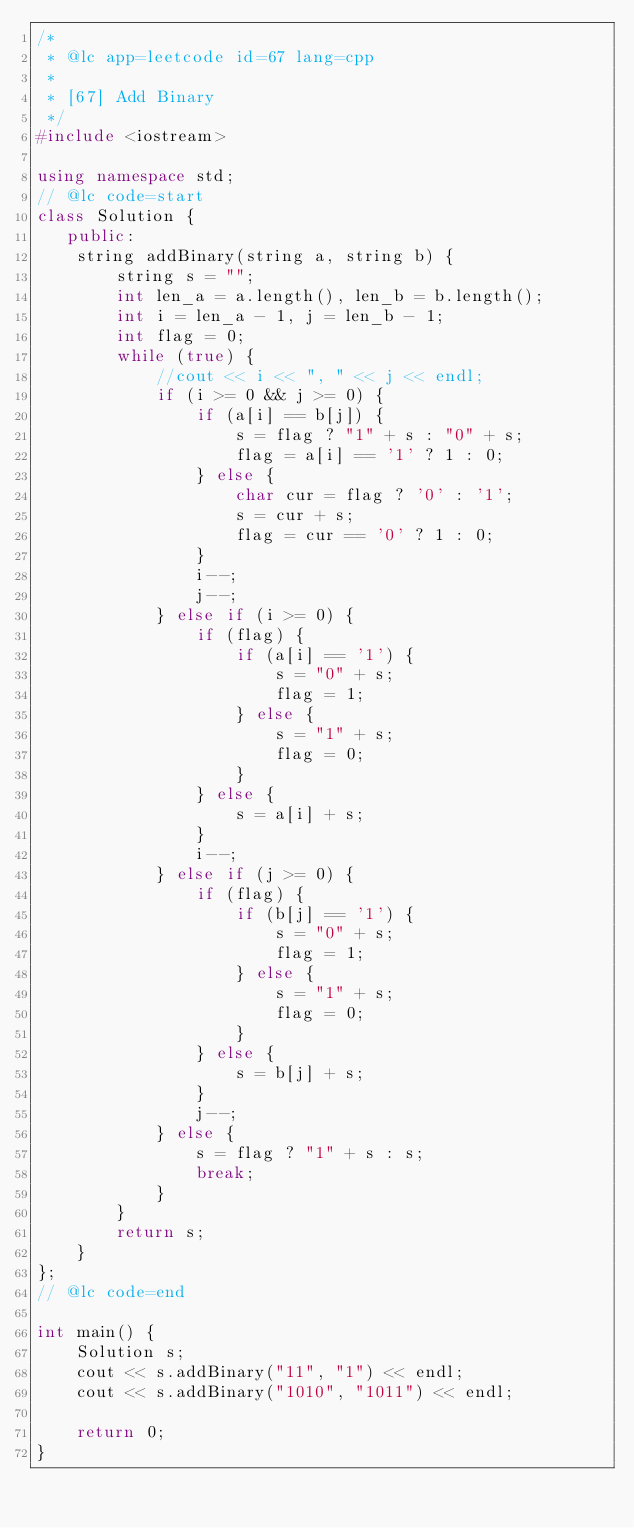<code> <loc_0><loc_0><loc_500><loc_500><_C++_>/*
 * @lc app=leetcode id=67 lang=cpp
 *
 * [67] Add Binary
 */
#include <iostream>

using namespace std;
// @lc code=start
class Solution {
   public:
    string addBinary(string a, string b) {
        string s = "";
        int len_a = a.length(), len_b = b.length();
        int i = len_a - 1, j = len_b - 1;
        int flag = 0;
        while (true) {
            //cout << i << ", " << j << endl;
            if (i >= 0 && j >= 0) {
                if (a[i] == b[j]) {
                    s = flag ? "1" + s : "0" + s;
                    flag = a[i] == '1' ? 1 : 0;
                } else {
                    char cur = flag ? '0' : '1';
                    s = cur + s;
                    flag = cur == '0' ? 1 : 0;
                }
                i--;
                j--;
            } else if (i >= 0) {
                if (flag) {
                    if (a[i] == '1') {
                        s = "0" + s;
                        flag = 1;
                    } else {
                        s = "1" + s;
                        flag = 0;
                    }
                } else {
                    s = a[i] + s;
                }
                i--;
            } else if (j >= 0) {
                if (flag) {
                    if (b[j] == '1') {
                        s = "0" + s;
                        flag = 1;
                    } else {
                        s = "1" + s;
                        flag = 0;
                    }
                } else {
                    s = b[j] + s;
                }
                j--;
            } else {
                s = flag ? "1" + s : s;
                break;
            }
        }
        return s;
    }
};
// @lc code=end

int main() {
    Solution s;
    cout << s.addBinary("11", "1") << endl;
    cout << s.addBinary("1010", "1011") << endl;

    return 0;
}
</code> 